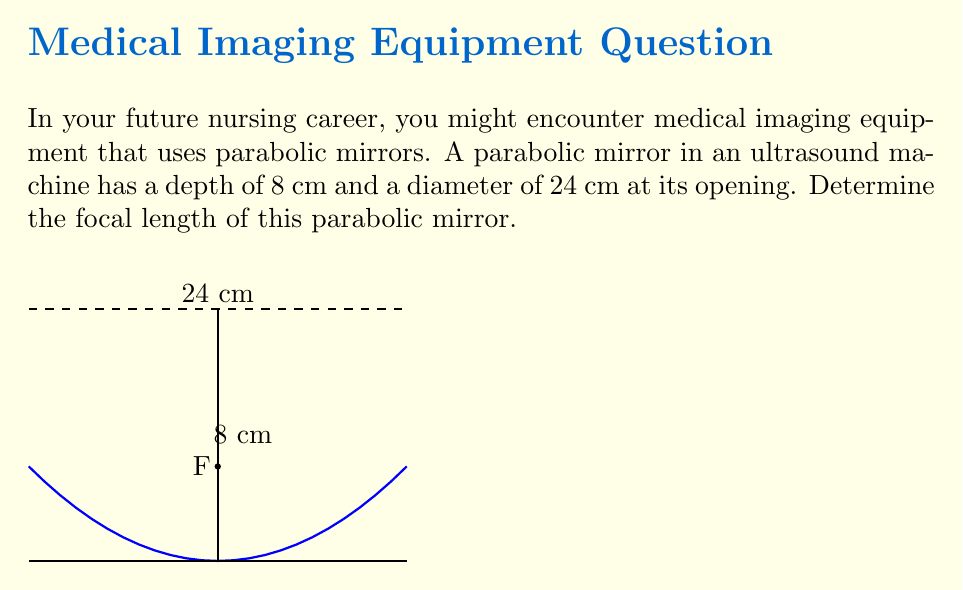Give your solution to this math problem. Let's approach this step-by-step:

1) The equation of a parabola with vertex at the origin and opening upward is:

   $$ y = \frac{1}{4a}x^2 $$

   where $a$ is the focal length.

2) We know the depth (8 cm) and the radius at the opening (12 cm, half of 24 cm). These correspond to the y and x coordinates of a point on the parabola.

3) Substituting these values into the equation:

   $$ 8 = \frac{1}{4a}(12^2) $$

4) Simplify:
   $$ 8 = \frac{144}{4a} $$

5) Multiply both sides by $4a$:
   $$ 32a = 144 $$

6) Divide both sides by 32:
   $$ a = \frac{144}{32} = 4.5 $$

Therefore, the focal length of the parabolic mirror is 4.5 cm.
Answer: 4.5 cm 